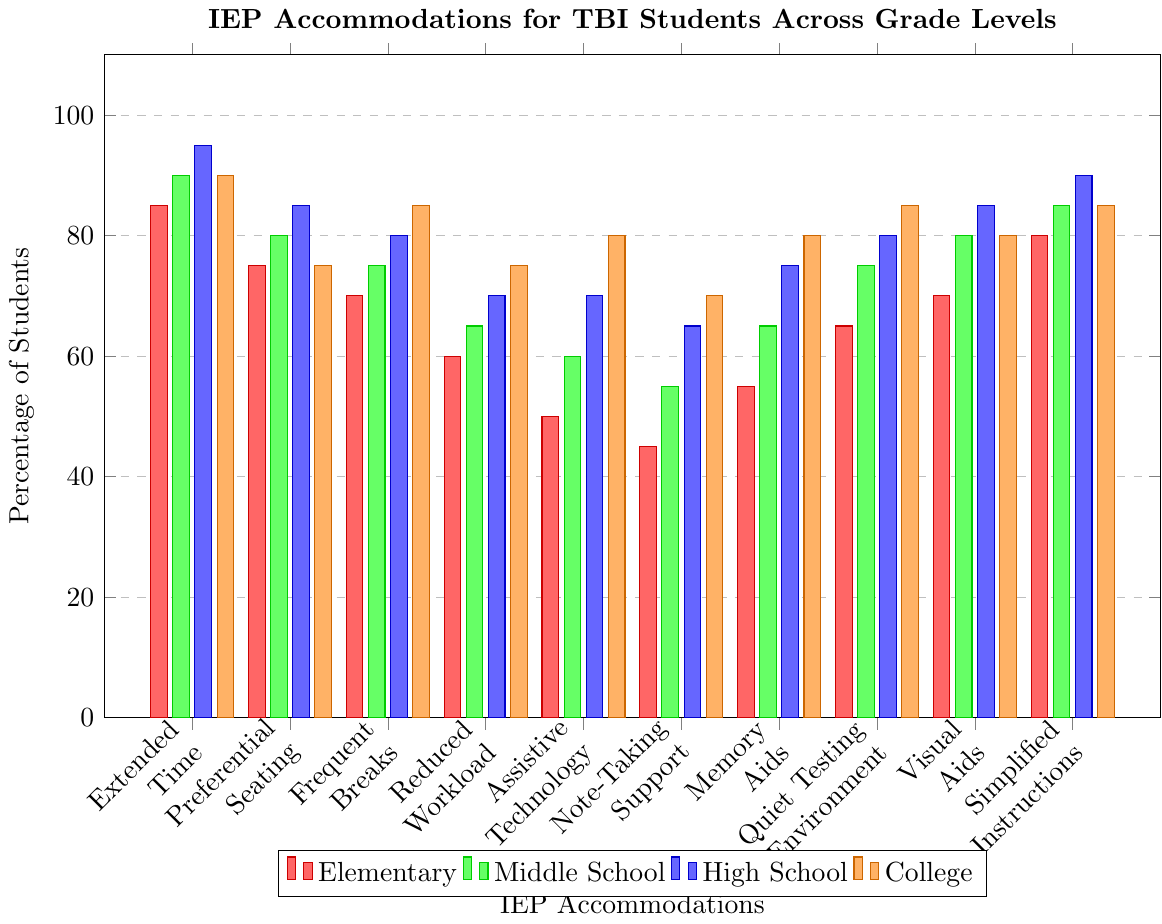What's the most common IEP accommodation for TBI students in High School? The tallest bar representing High School in the figure shows simplified instructions at 90%.
Answer: Simplified Instructions Which grade level uses assistive technology the most? The tallest bar for assistive technology occurs in College at 80%.
Answer: College What is the difference in the percentage of students using frequent breaks between Elementary and College? The bar for frequent breaks is 70% for Elementary and 85% for College. The difference is 85% - 70% = 15%.
Answer: 15% Do Middle School students use memory aids more than note-taking support? The height of the bar for memory aids in Middle School is 65%, whereas for note-taking support it is 55%, indicating that memory aids are used more.
Answer: Yes Compare the percentage of students with preferential seating accommodation between Elementary and High School. The bar for preferential seating in Elementary is 75%, while in High School it is 85%. Therefore, the percentage is higher in High School.
Answer: High School What is the least common IEP accommodation for TBI students in Elementary? The shortest bar for Elementary is assistive technology at 50%.
Answer: Assistive Technology Calculate the average percentage of students using quiet testing environments across all grade levels. The percentages for quiet testing environments are as follows: Elementary (65%), Middle School (75%), High School (80%), and College (85%). The average is (65 + 75 + 80 + 85) / 4 = 305 / 4 = 76.25.
Answer: 76.25% Compare the use of visual aids between Elementary and Middle School. Both Elementary and Middle School have the same percentage for visual aids, which is 70% and 80%, respectively. Therefore, no difference is observed.
Answer: Equal In which grade level is reduced workload least commonly used? The shortest bar in the reduced workload category is in Elementary at 60%.
Answer: Elementary What is the percentage range for note-taking support across all grade levels? The percentages for note-taking support are: Elementary (45%), Middle School (55%), High School (65%), College (70%). The range is 70% - 45% = 25%.
Answer: 25% 